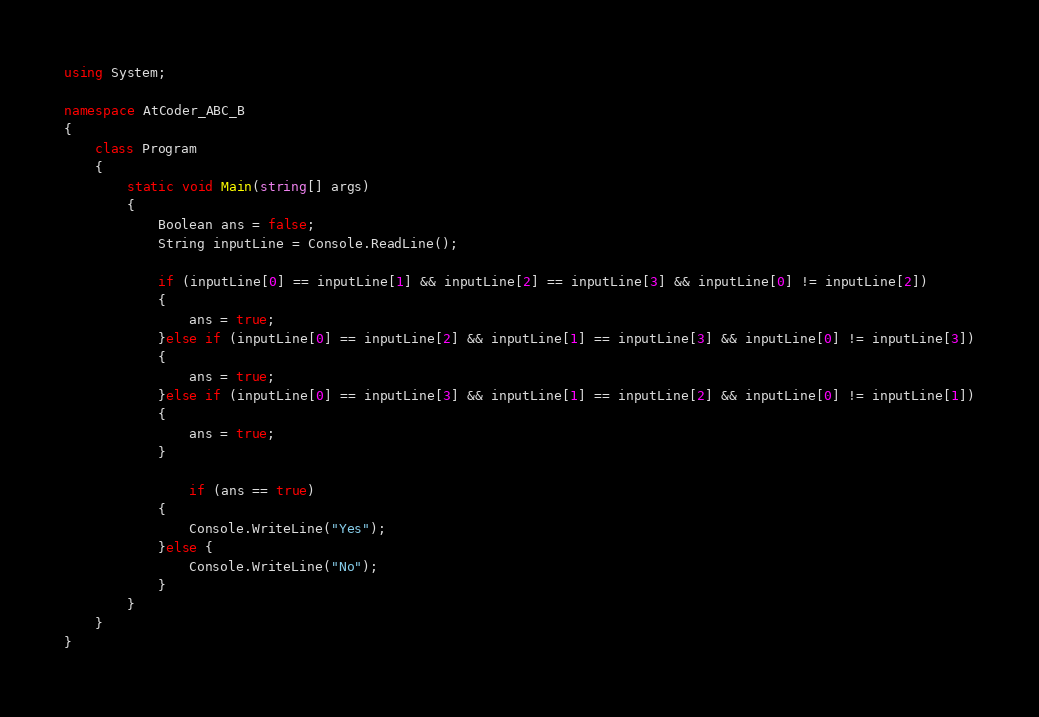<code> <loc_0><loc_0><loc_500><loc_500><_C#_>using System;

namespace AtCoder_ABC_B
{
    class Program
    {
        static void Main(string[] args)
        {
            Boolean ans = false;
            String inputLine = Console.ReadLine();

            if (inputLine[0] == inputLine[1] && inputLine[2] == inputLine[3] && inputLine[0] != inputLine[2]) 
            {
                ans = true;
            }else if (inputLine[0] == inputLine[2] && inputLine[1] == inputLine[3] && inputLine[0] != inputLine[3])
            {
                ans = true;
            }else if (inputLine[0] == inputLine[3] && inputLine[1] == inputLine[2] && inputLine[0] != inputLine[1])
            {
                ans = true;
            }

                if (ans == true)
            {
                Console.WriteLine("Yes");
            }else {
                Console.WriteLine("No");
            }
        }
    }
}
</code> 